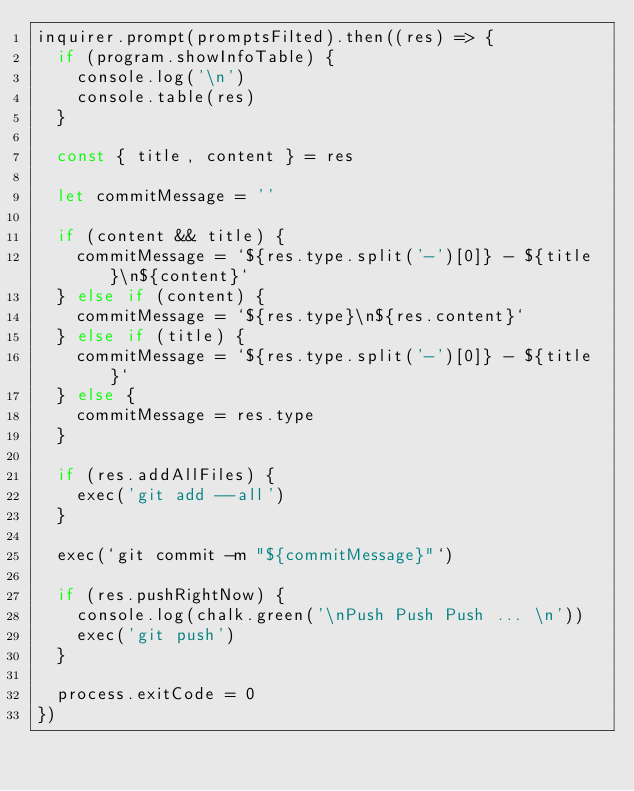Convert code to text. <code><loc_0><loc_0><loc_500><loc_500><_JavaScript_>inquirer.prompt(promptsFilted).then((res) => {
  if (program.showInfoTable) {
    console.log('\n')
    console.table(res)
  }

  const { title, content } = res

  let commitMessage = ''

  if (content && title) {
    commitMessage = `${res.type.split('-')[0]} - ${title}\n${content}`
  } else if (content) {
    commitMessage = `${res.type}\n${res.content}`
  } else if (title) {
    commitMessage = `${res.type.split('-')[0]} - ${title}`
  } else {
    commitMessage = res.type
  }

  if (res.addAllFiles) {
    exec('git add --all')
  }

  exec(`git commit -m "${commitMessage}"`)

  if (res.pushRightNow) {
    console.log(chalk.green('\nPush Push Push ... \n'))
    exec('git push')
  }

  process.exitCode = 0
})
</code> 